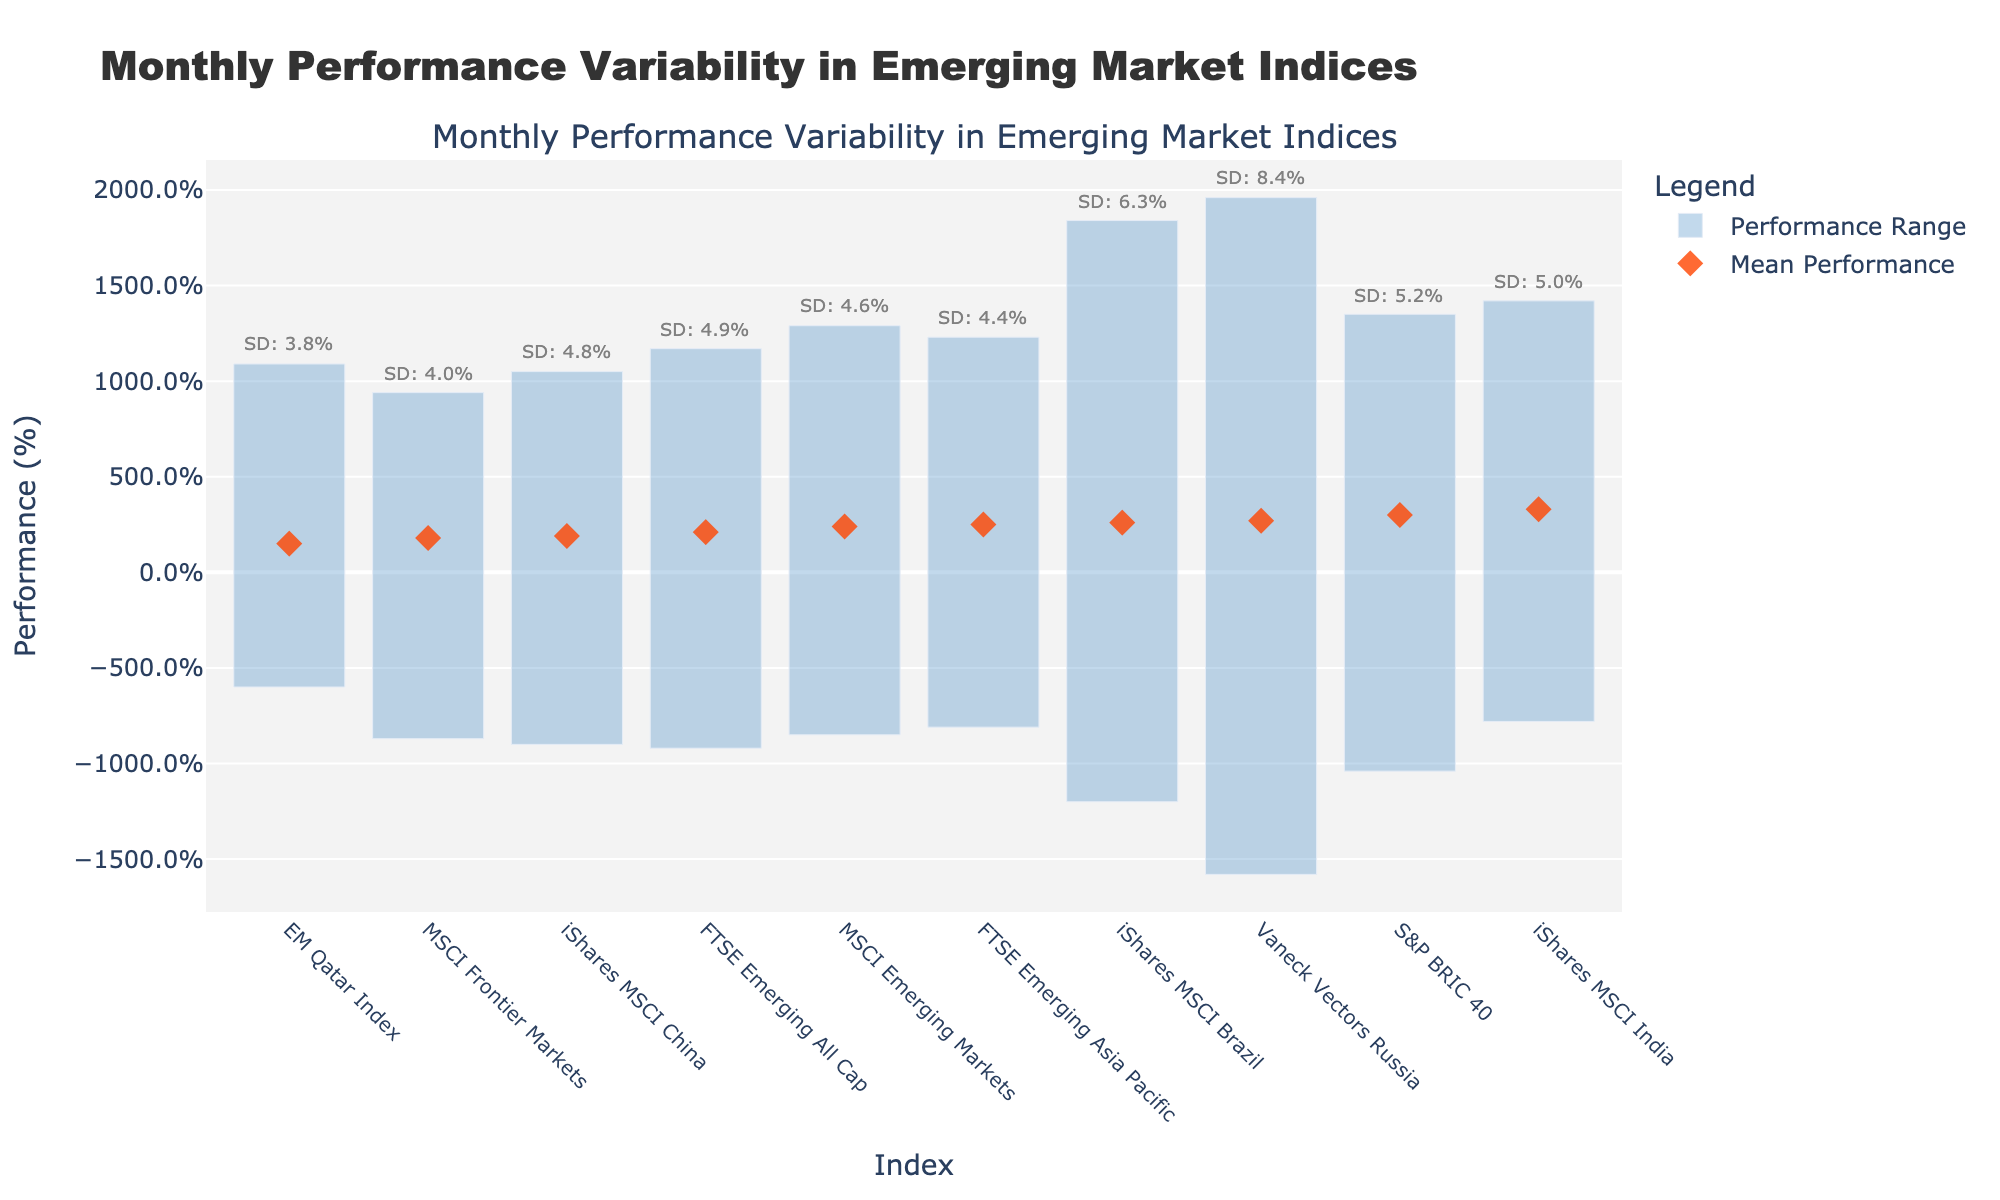What's the title of the plot? The title is displayed at the top of the plot. It reads "Monthly Performance Variability in Emerging Market Indices".
Answer: Monthly Performance Variability in Emerging Market Indices What does the X-axis represent? The X-axis lists the names of various emerging market indices, each indicating a different country or region.
Answer: Emerging market indices What does the Y-axis represent? The Y-axis represents the performance percentage, ranging from the minimum to the maximum performance of each index.
Answer: Performance (%) How many indices are illustrated in the plot? By counting the number of labels on the X-axis, we find there are 10 different indices.
Answer: 10 Which index has the highest maximum performance? By looking at the highest point on the Y-axis for each bar, the Vaneck Vectors Russia index has the highest maximum performance at 19.6%.
Answer: Vaneck Vectors Russia Which index has the greatest performance variability? The performance variability is the range between the minimum and maximum performances. The Vaneck Vectors Russia index shows the greatest variability from -15.8% to 19.6%, making it 35.4% in total.
Answer: Vaneck Vectors Russia What is the mean performance of the iShares MSCI India index? Locate the diamond marker for the iShares MSCI India index on the Y-axis, which represents the mean performance, and note its position.
Answer: 3.3% How does the performance range of MSCI Frontier Markets compare to the performance range of EM Qatar Index? The MSCI Frontier Markets index has a performance range from -8.7% to 9.4%, and the EM Qatar Index ranges from -6.0% to 10.9%. The range for MSCI Frontier Markets is 18.1% while the range for EM Qatar Index is 16.9%. Thus, MSCI Frontier Markets has a slightly larger range.
Answer: MSCI Frontier Markets has a larger range Which index has the lowest mean performance? Identify the lowest diamond marker on the plot which represents mean performances. The EM Qatar Index has the lowest mean performance at 1.5%.
Answer: EM Qatar Index What is the standard deviation of the iShares MSCI Brazil index? Look for the annotation attached to the maximum performance value of the iShares MSCI Brazil index; it specifies the standard deviation.
Answer: 6.3% 